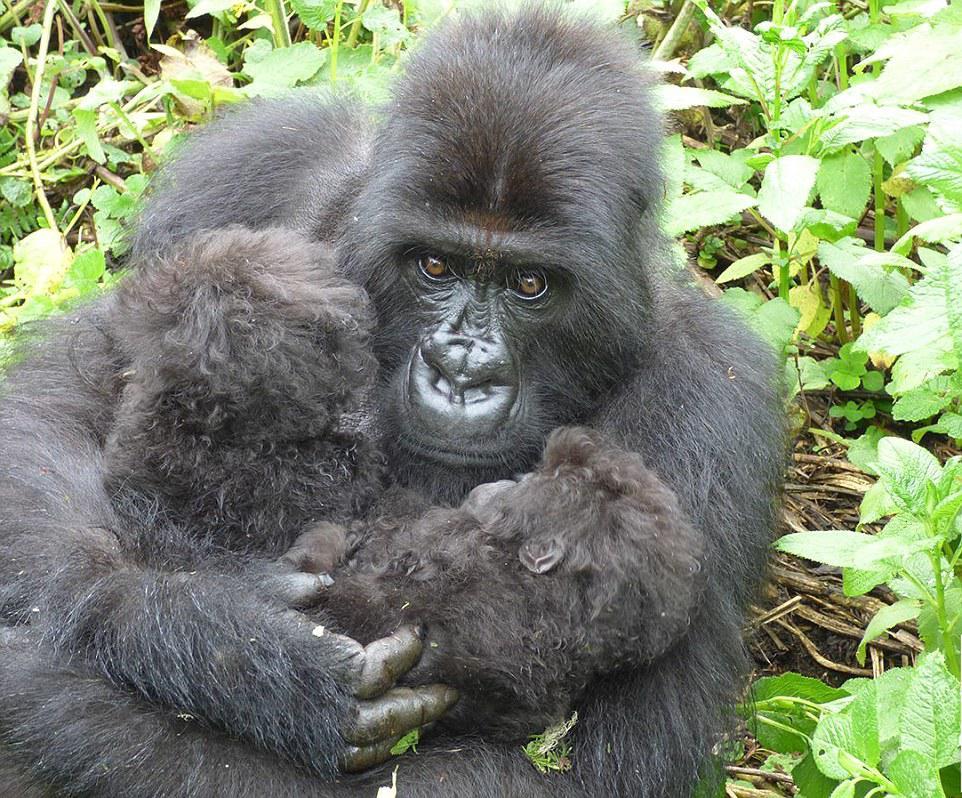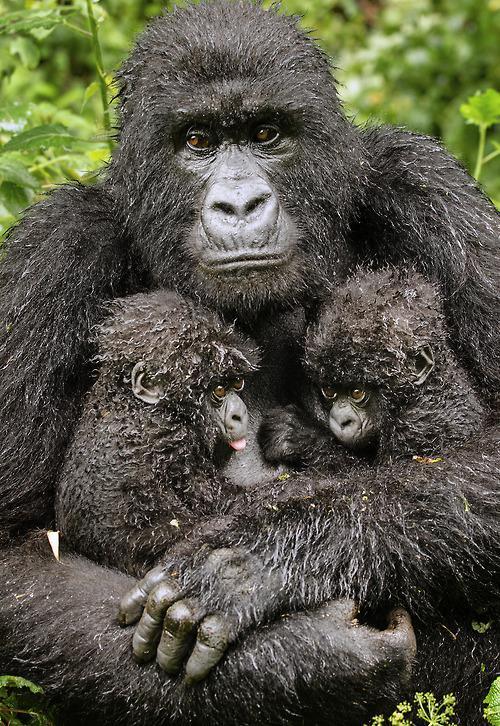The first image is the image on the left, the second image is the image on the right. Assess this claim about the two images: "Each image shows an upright adult gorilla with two baby gorillas in front of it, and at least one of the images shows the baby gorillas face-to-face and on the adult gorilla's chest.". Correct or not? Answer yes or no. Yes. The first image is the image on the left, the second image is the image on the right. Assess this claim about the two images: "In each image, two baby gorillas are by their mother.". Correct or not? Answer yes or no. Yes. 